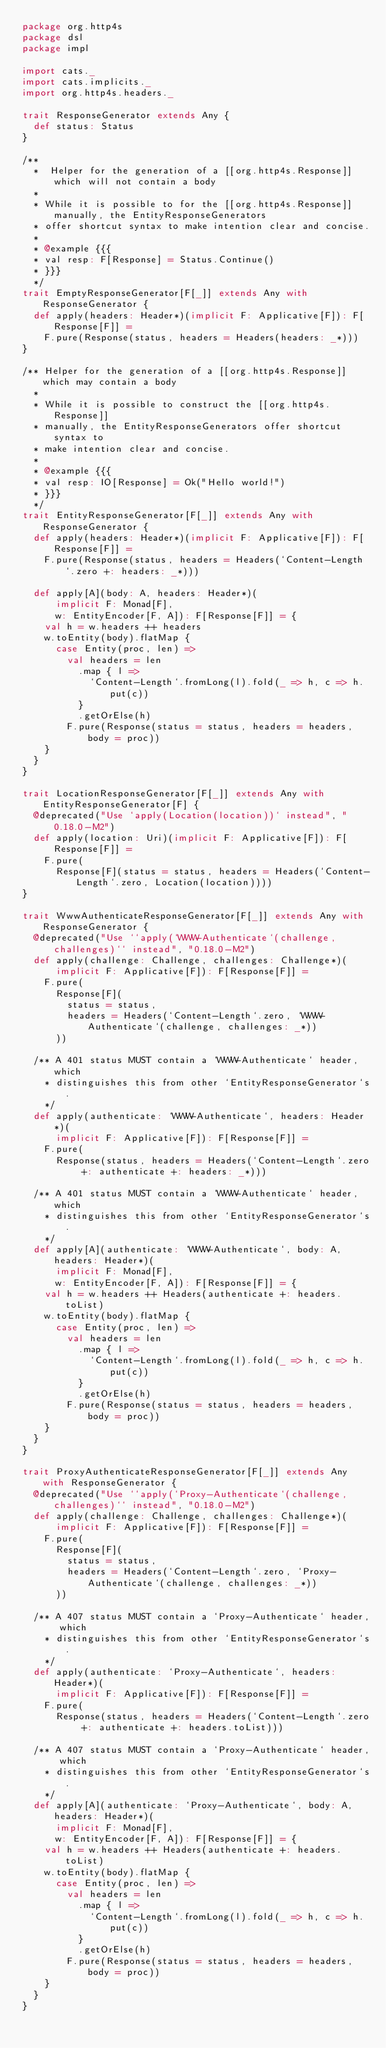<code> <loc_0><loc_0><loc_500><loc_500><_Scala_>package org.http4s
package dsl
package impl

import cats._
import cats.implicits._
import org.http4s.headers._

trait ResponseGenerator extends Any {
  def status: Status
}

/**
  *  Helper for the generation of a [[org.http4s.Response]] which will not contain a body
  *
  * While it is possible to for the [[org.http4s.Response]] manually, the EntityResponseGenerators
  * offer shortcut syntax to make intention clear and concise.
  *
  * @example {{{
  * val resp: F[Response] = Status.Continue()
  * }}}
  */
trait EmptyResponseGenerator[F[_]] extends Any with ResponseGenerator {
  def apply(headers: Header*)(implicit F: Applicative[F]): F[Response[F]] =
    F.pure(Response(status, headers = Headers(headers: _*)))
}

/** Helper for the generation of a [[org.http4s.Response]] which may contain a body
  *
  * While it is possible to construct the [[org.http4s.Response]]
  * manually, the EntityResponseGenerators offer shortcut syntax to
  * make intention clear and concise.
  *
  * @example {{{
  * val resp: IO[Response] = Ok("Hello world!")
  * }}}
  */
trait EntityResponseGenerator[F[_]] extends Any with ResponseGenerator {
  def apply(headers: Header*)(implicit F: Applicative[F]): F[Response[F]] =
    F.pure(Response(status, headers = Headers(`Content-Length`.zero +: headers: _*)))

  def apply[A](body: A, headers: Header*)(
      implicit F: Monad[F],
      w: EntityEncoder[F, A]): F[Response[F]] = {
    val h = w.headers ++ headers
    w.toEntity(body).flatMap {
      case Entity(proc, len) =>
        val headers = len
          .map { l =>
            `Content-Length`.fromLong(l).fold(_ => h, c => h.put(c))
          }
          .getOrElse(h)
        F.pure(Response(status = status, headers = headers, body = proc))
    }
  }
}

trait LocationResponseGenerator[F[_]] extends Any with EntityResponseGenerator[F] {
  @deprecated("Use `apply(Location(location))` instead", "0.18.0-M2")
  def apply(location: Uri)(implicit F: Applicative[F]): F[Response[F]] =
    F.pure(
      Response[F](status = status, headers = Headers(`Content-Length`.zero, Location(location))))
}

trait WwwAuthenticateResponseGenerator[F[_]] extends Any with ResponseGenerator {
  @deprecated("Use ``apply(`WWW-Authenticate`(challenge, challenges)`` instead", "0.18.0-M2")
  def apply(challenge: Challenge, challenges: Challenge*)(
      implicit F: Applicative[F]): F[Response[F]] =
    F.pure(
      Response[F](
        status = status,
        headers = Headers(`Content-Length`.zero, `WWW-Authenticate`(challenge, challenges: _*))
      ))

  /** A 401 status MUST contain a `WWW-Authenticate` header, which
    * distinguishes this from other `EntityResponseGenerator`s.
    */
  def apply(authenticate: `WWW-Authenticate`, headers: Header*)(
      implicit F: Applicative[F]): F[Response[F]] =
    F.pure(
      Response(status, headers = Headers(`Content-Length`.zero +: authenticate +: headers: _*)))

  /** A 401 status MUST contain a `WWW-Authenticate` header, which
    * distinguishes this from other `EntityResponseGenerator`s.
    */
  def apply[A](authenticate: `WWW-Authenticate`, body: A, headers: Header*)(
      implicit F: Monad[F],
      w: EntityEncoder[F, A]): F[Response[F]] = {
    val h = w.headers ++ Headers(authenticate +: headers.toList)
    w.toEntity(body).flatMap {
      case Entity(proc, len) =>
        val headers = len
          .map { l =>
            `Content-Length`.fromLong(l).fold(_ => h, c => h.put(c))
          }
          .getOrElse(h)
        F.pure(Response(status = status, headers = headers, body = proc))
    }
  }
}

trait ProxyAuthenticateResponseGenerator[F[_]] extends Any with ResponseGenerator {
  @deprecated("Use ``apply(`Proxy-Authenticate`(challenge, challenges)`` instead", "0.18.0-M2")
  def apply(challenge: Challenge, challenges: Challenge*)(
      implicit F: Applicative[F]): F[Response[F]] =
    F.pure(
      Response[F](
        status = status,
        headers = Headers(`Content-Length`.zero, `Proxy-Authenticate`(challenge, challenges: _*))
      ))

  /** A 407 status MUST contain a `Proxy-Authenticate` header, which
    * distinguishes this from other `EntityResponseGenerator`s.
    */
  def apply(authenticate: `Proxy-Authenticate`, headers: Header*)(
      implicit F: Applicative[F]): F[Response[F]] =
    F.pure(
      Response(status, headers = Headers(`Content-Length`.zero +: authenticate +: headers.toList)))

  /** A 407 status MUST contain a `Proxy-Authenticate` header, which
    * distinguishes this from other `EntityResponseGenerator`s.
    */
  def apply[A](authenticate: `Proxy-Authenticate`, body: A, headers: Header*)(
      implicit F: Monad[F],
      w: EntityEncoder[F, A]): F[Response[F]] = {
    val h = w.headers ++ Headers(authenticate +: headers.toList)
    w.toEntity(body).flatMap {
      case Entity(proc, len) =>
        val headers = len
          .map { l =>
            `Content-Length`.fromLong(l).fold(_ => h, c => h.put(c))
          }
          .getOrElse(h)
        F.pure(Response(status = status, headers = headers, body = proc))
    }
  }
}
</code> 